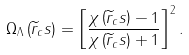<formula> <loc_0><loc_0><loc_500><loc_500>\Omega _ { \Lambda } \left ( \widetilde { r } _ { c } s \right ) = \left [ \frac { \chi \left ( \widetilde { r } _ { c } s \right ) - 1 } { \chi \left ( \widetilde { r } _ { c } s \right ) + 1 } \right ] ^ { 2 } .</formula> 